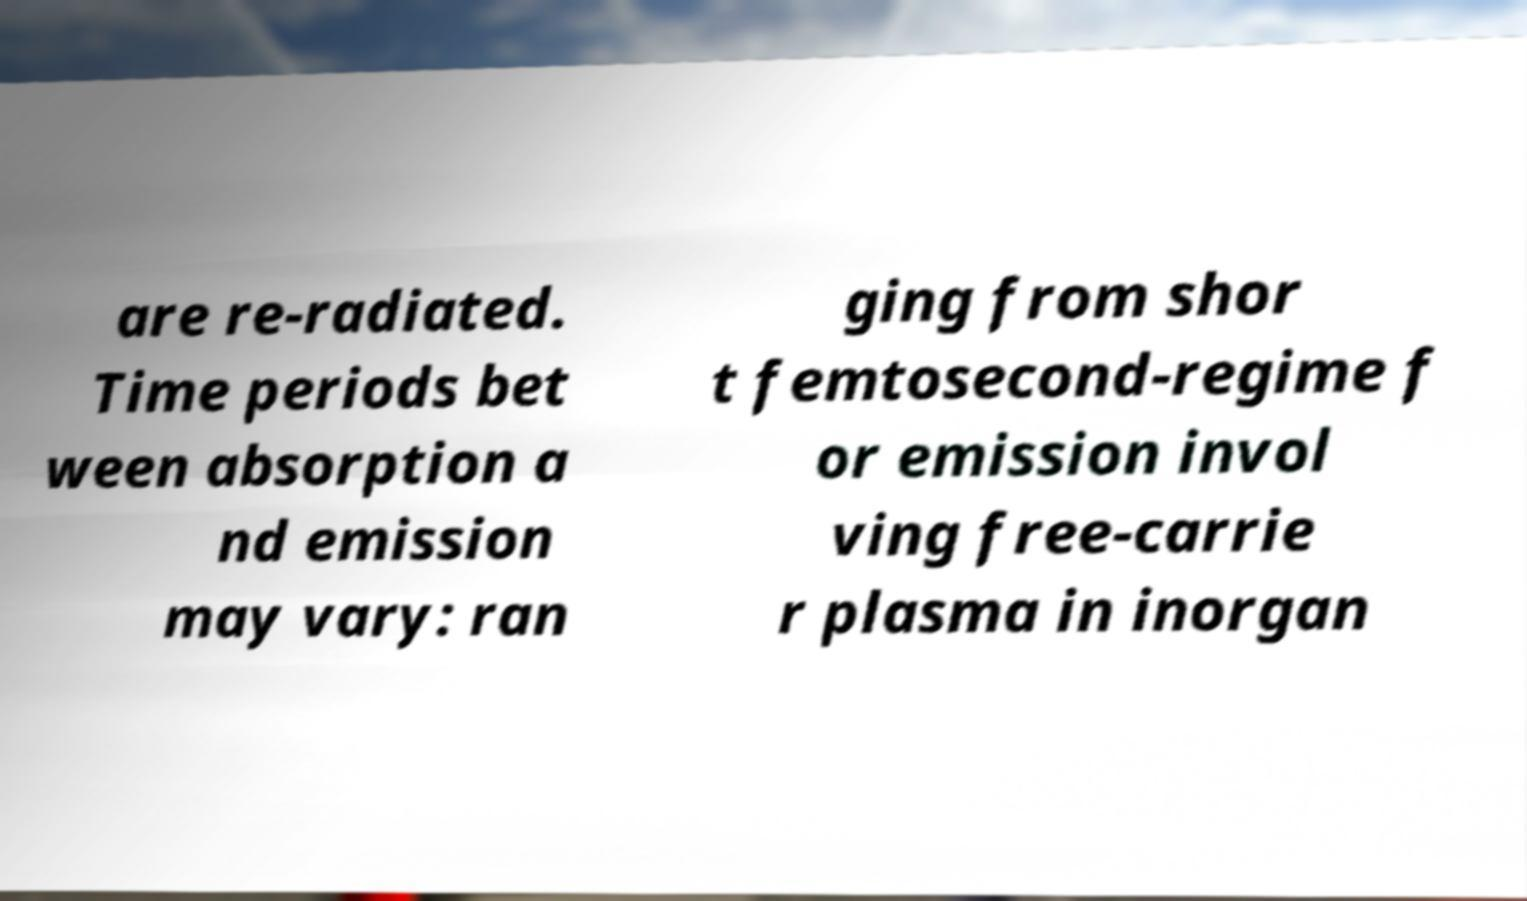Can you accurately transcribe the text from the provided image for me? are re-radiated. Time periods bet ween absorption a nd emission may vary: ran ging from shor t femtosecond-regime f or emission invol ving free-carrie r plasma in inorgan 